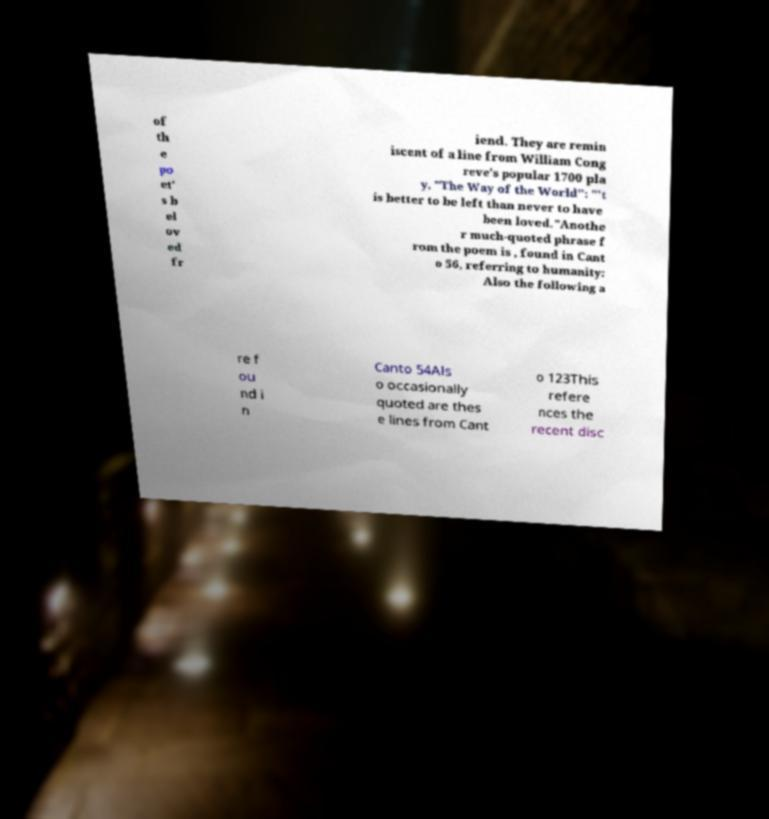There's text embedded in this image that I need extracted. Can you transcribe it verbatim? of th e po et' s b el ov ed fr iend. They are remin iscent of a line from William Cong reve's popular 1700 pla y, "The Way of the World": "'t is better to be left than never to have been loved."Anothe r much-quoted phrase f rom the poem is , found in Cant o 56, referring to humanity: Also the following a re f ou nd i n Canto 54Als o occasionally quoted are thes e lines from Cant o 123This refere nces the recent disc 